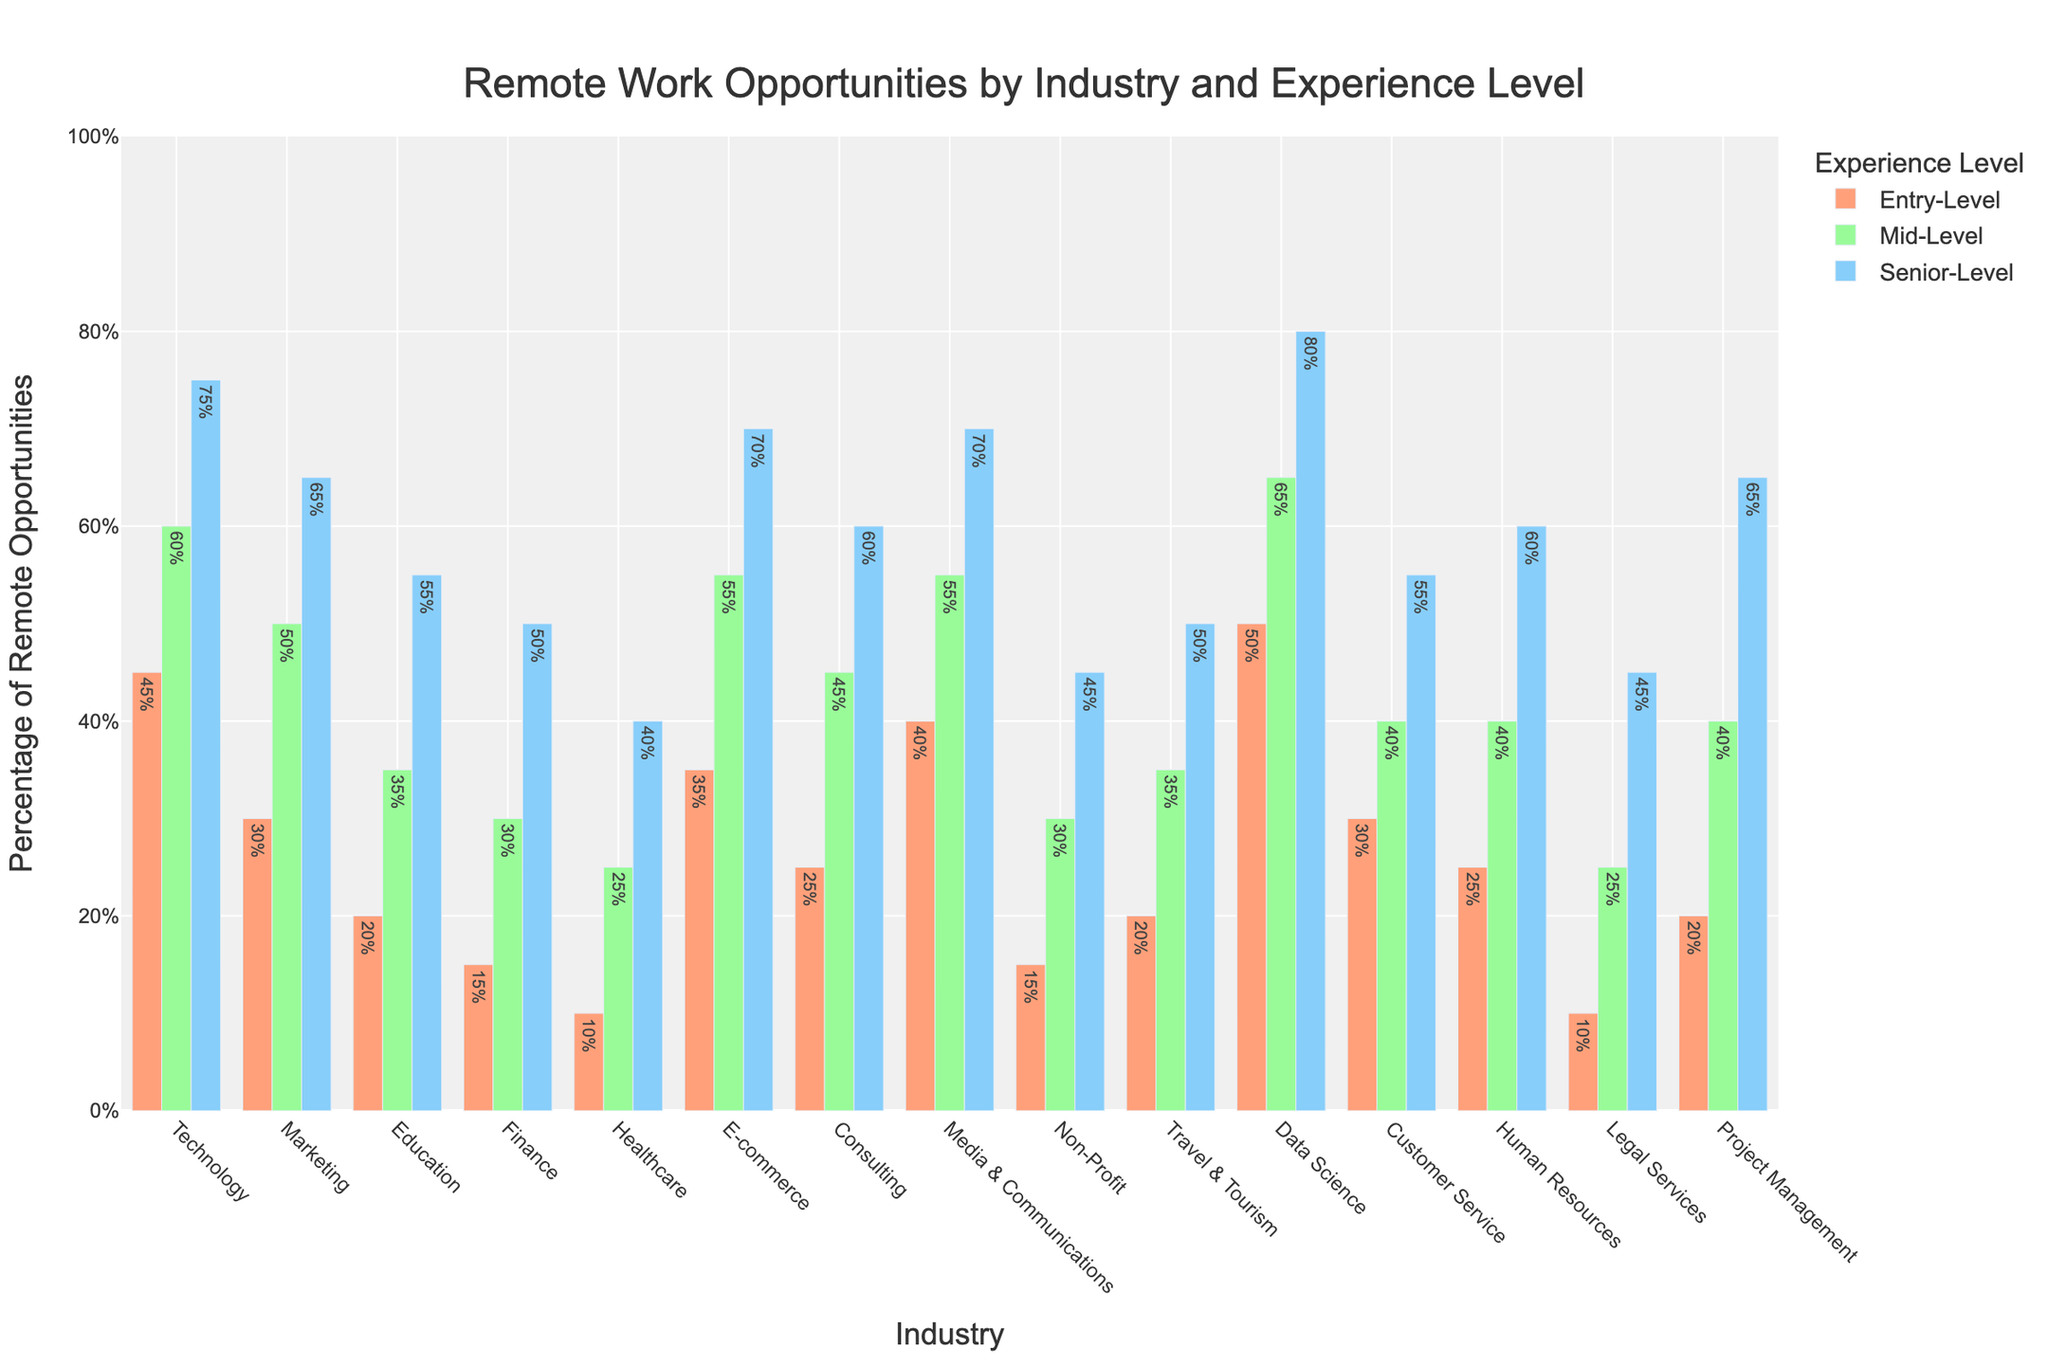Which industry offers the highest percentage of remote opportunities for senior-level jobs? The 'Senior-Level' bar is the highest for 'Data Science,' so it offers the highest percentage of remote opportunities.
Answer: Data Science Which industry has the lowest percentage of remote opportunities at the entry-level? The 'Entry-Level' bar is shortest for 'Healthcare,' indicating it has the lowest percentage of remote opportunities.
Answer: Healthcare Compare the percentage of remote opportunities in 'Technology' for entry-level and mid-level positions. What's the difference? The bar heights indicate 'Technology' has 45% for entry-level and 60% for mid-level. The difference is 60% - 45% = 15%.
Answer: 15% How do the remote opportunities in 'Marketing' for senior-level compare to those in 'Finance' for the same level? The 'Senior-Level' bar for 'Marketing' shows 65%, whereas 'Finance' shows 50%, so 'Marketing' has a higher percentage.
Answer: Marketing What is the average percentage of remote opportunities in 'Consulting' across all experience levels? Sum the percentages (25% + 45% + 60%) and divide by 3 to get the average. (25% + 45% + 60%) / 3 = 43.33%.
Answer: 43.33% Between 'Media & Communications' and 'E-commerce,' which industry offers more remote opportunities at the mid-level? Compare the 'Mid-Level' bars: 'Media & Communications' has 55% and 'E-commerce' has 55%. Both industries are equal in remote opportunities at the mid-level.
Answer: Equal What’s the total percentage difference in remote opportunities between 'Non-Profit' and 'Project Management' for senior-level positions? The difference is found by subtracting 45% ('Non-Profit') from 65% ('Project Management') to get 20%.
Answer: 20% Is the percentage of remote opportunities for entry-level in 'Customer Service' higher or lower than that in 'Human Resources'? Comparing 'Entry-Level' bars: 'Customer Service' has 30% and 'Human Resources' has 25%, so 'Customer Service' is higher.
Answer: Higher What's the combined percentage of remote opportunities for senior-level across 'Technology' and 'Data Science'? Add the figures for 'Senior-Level': 'Technology' (75%) and 'Data Science' (80%) to get 75% + 80% = 155%.
Answer: 155% 